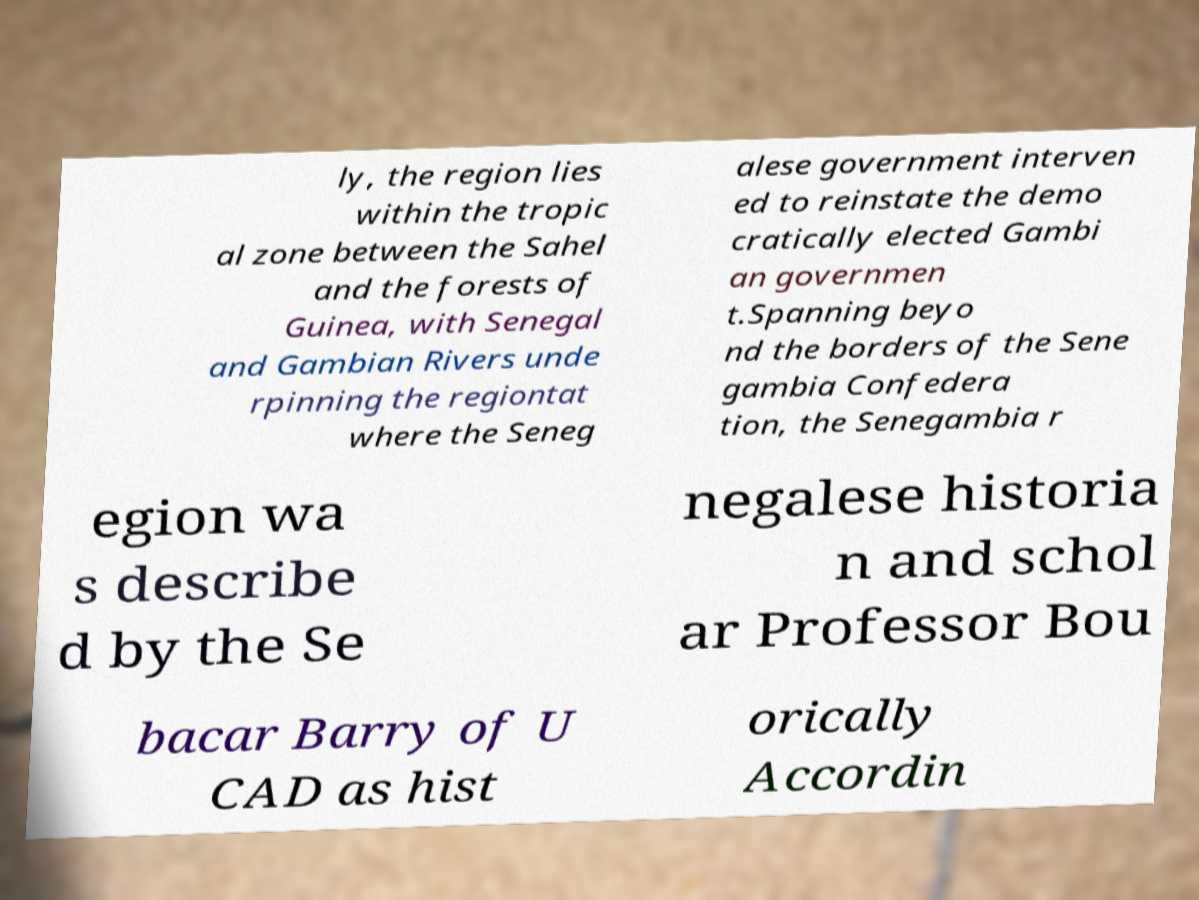Please identify and transcribe the text found in this image. ly, the region lies within the tropic al zone between the Sahel and the forests of Guinea, with Senegal and Gambian Rivers unde rpinning the regiontat where the Seneg alese government interven ed to reinstate the demo cratically elected Gambi an governmen t.Spanning beyo nd the borders of the Sene gambia Confedera tion, the Senegambia r egion wa s describe d by the Se negalese historia n and schol ar Professor Bou bacar Barry of U CAD as hist orically Accordin 